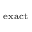Convert formula to latex. <formula><loc_0><loc_0><loc_500><loc_500>_ { e x a c t }</formula> 